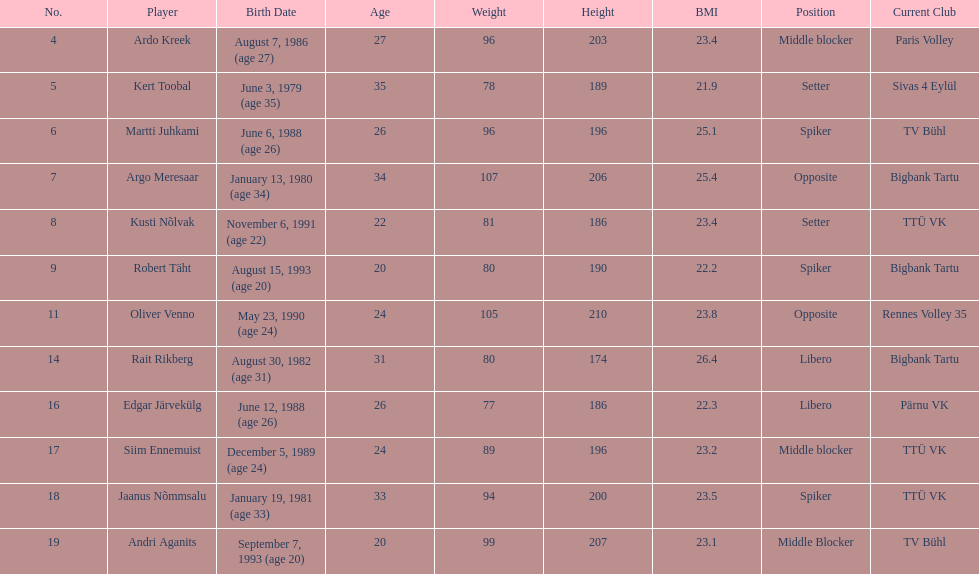Who is at least 25 years or older? Ardo Kreek, Kert Toobal, Martti Juhkami, Argo Meresaar, Rait Rikberg, Edgar Järvekülg, Jaanus Nõmmsalu. 